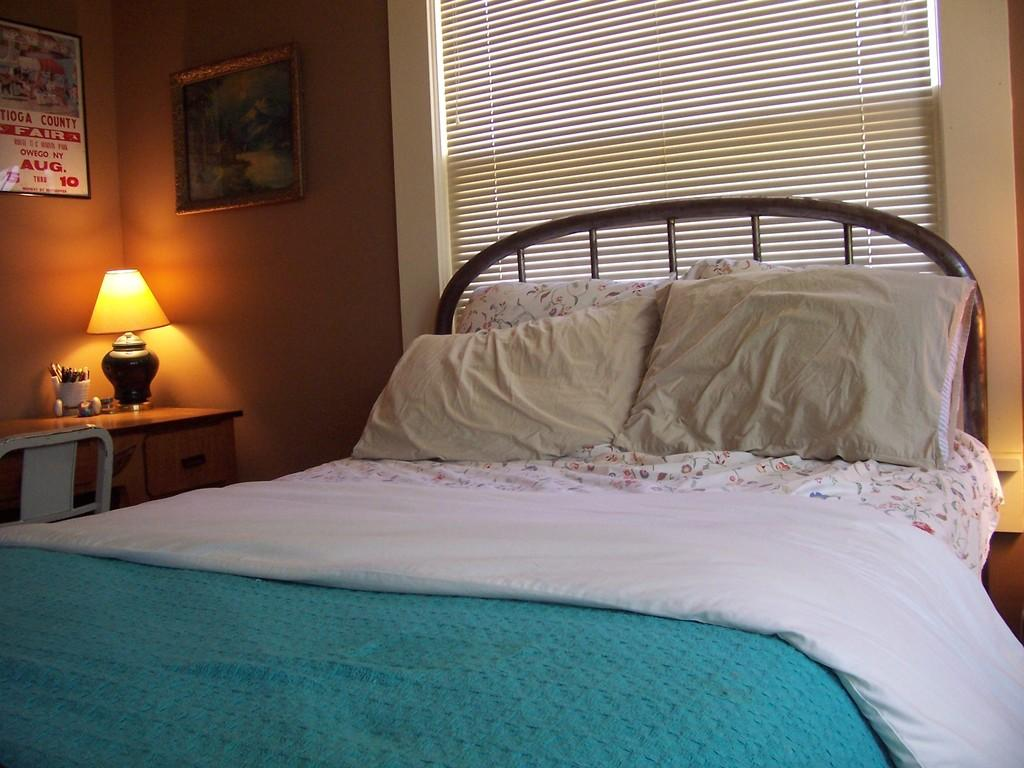What is the main object in the center of the image? There is a bed in the center of the image. What is covering the bed? There is a blanket on the bed. How many pillows are on the bed? There are two pillows on the bed. What can be seen in the background of the image? There is a wall, a window, a photo frame, a table, a chair, pens, headphones, and a lamp in the background of the image. What type of tin can be seen in the circle in the image? There is no tin or circle present in the image. 